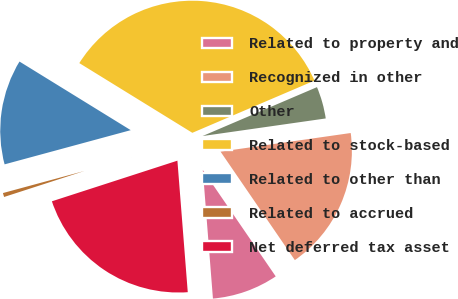Convert chart to OTSL. <chart><loc_0><loc_0><loc_500><loc_500><pie_chart><fcel>Related to property and<fcel>Recognized in other<fcel>Other<fcel>Related to stock-based<fcel>Related to other than<fcel>Related to accrued<fcel>Net deferred tax asset<nl><fcel>8.31%<fcel>17.7%<fcel>4.17%<fcel>34.78%<fcel>13.01%<fcel>0.77%<fcel>21.27%<nl></chart> 